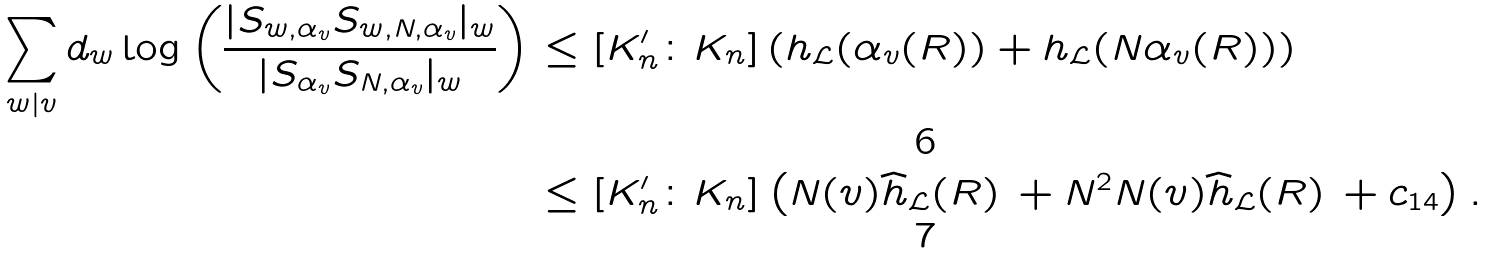Convert formula to latex. <formula><loc_0><loc_0><loc_500><loc_500>\sum _ { w | v } d _ { w } \log \left ( \frac { | S _ { w , \alpha _ { v } } S _ { w , N , \alpha _ { v } } | _ { w } } { | S _ { \alpha _ { v } } S _ { N , \alpha _ { v } } | _ { w } } \right ) & \leq [ K _ { n } ^ { \prime } \colon K _ { n } ] \left ( h _ { \mathcal { L } } ( \alpha _ { v } ( R ) ) + h _ { \mathcal { L } } ( N \alpha _ { v } ( R ) ) \right ) \\ & \leq [ K _ { n } ^ { \prime } \colon K _ { n } ] \left ( N ( v ) \widehat { h } _ { \mathcal { L } } ( R ) \, + N ^ { 2 } N ( v ) \widehat { h } _ { \mathcal { L } } ( R ) \, + c _ { 1 4 } \right ) .</formula> 